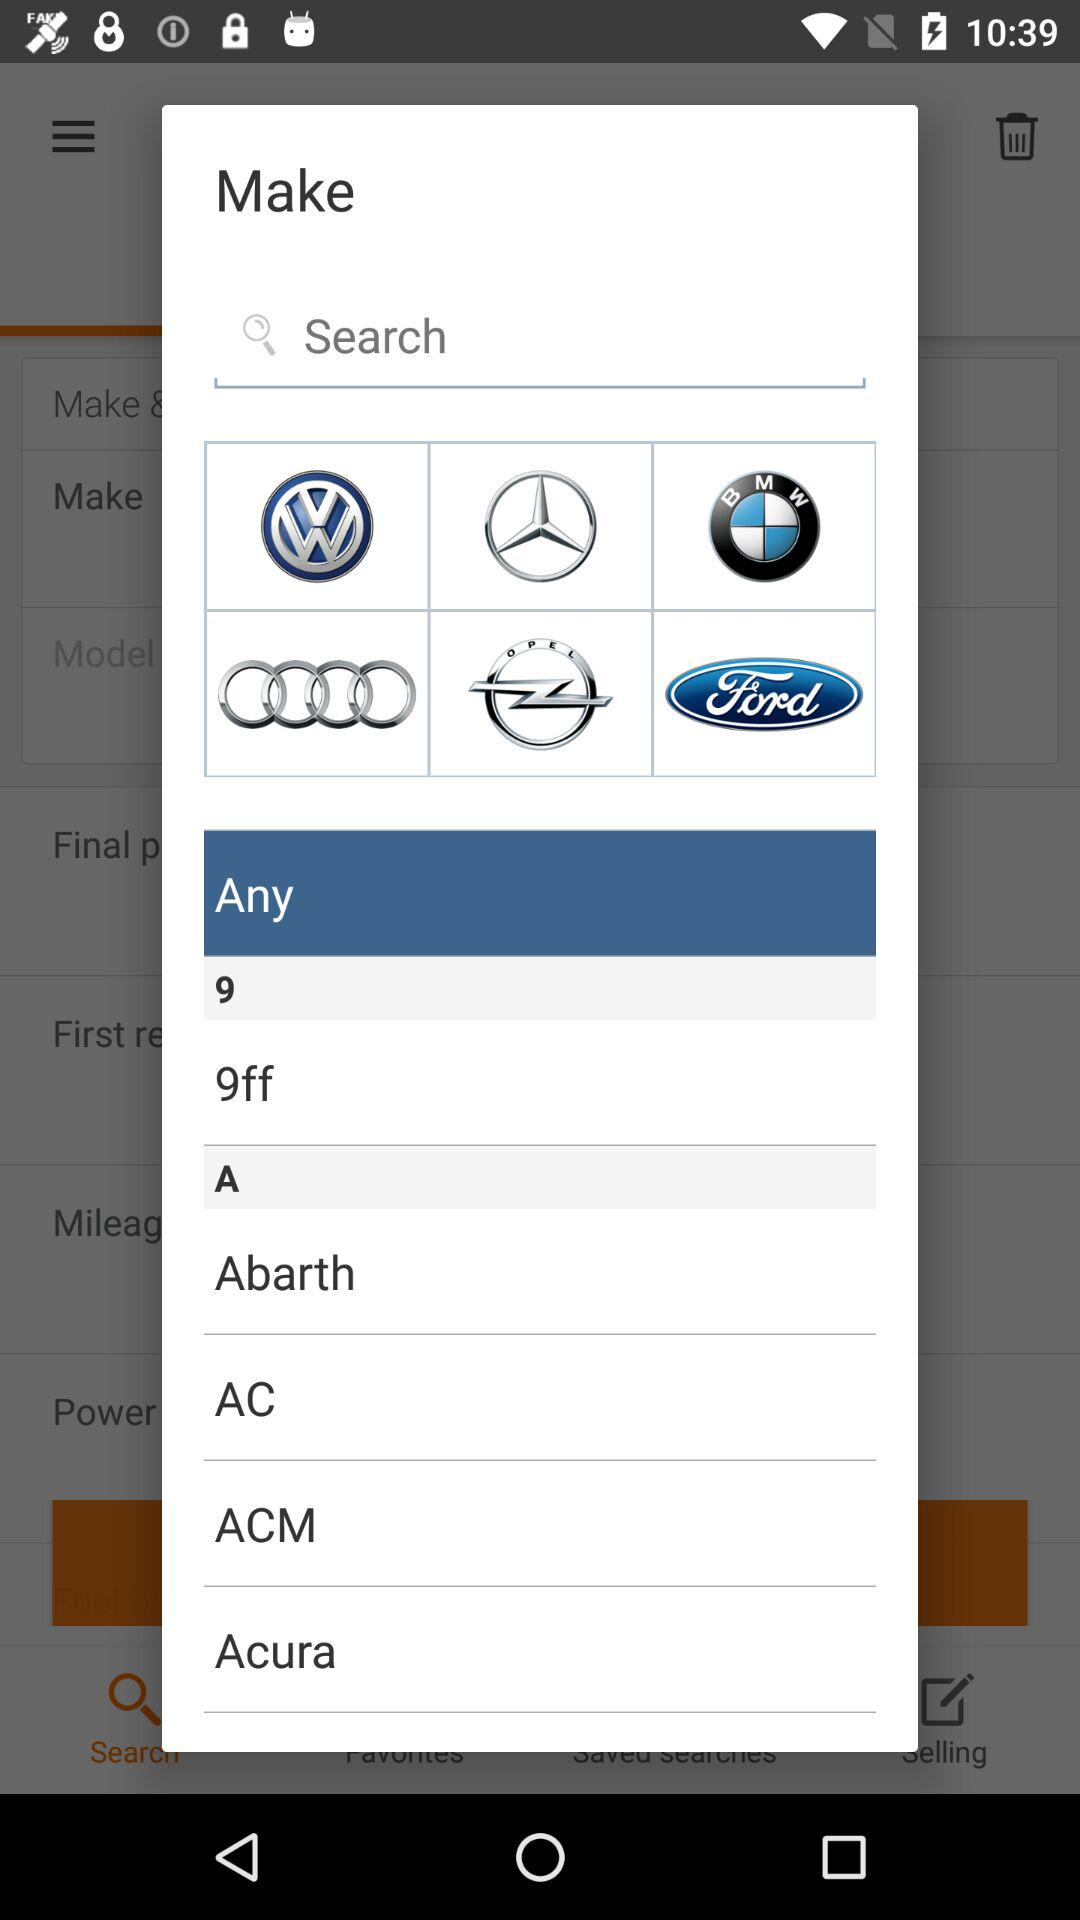Which option is selected? The selected option is "Any". 